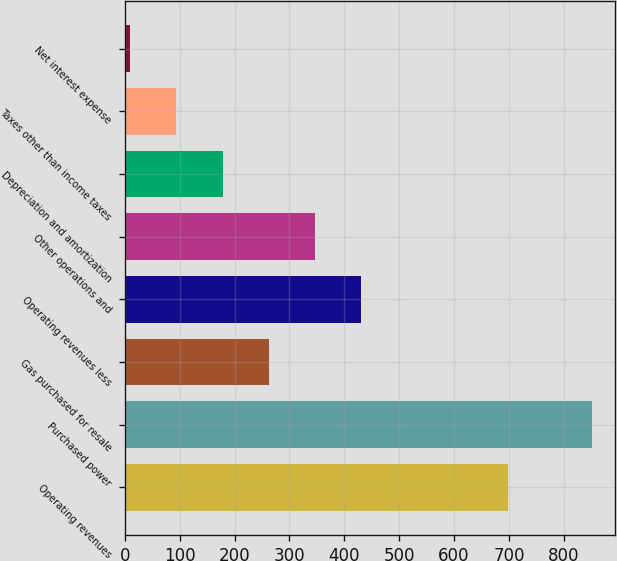<chart> <loc_0><loc_0><loc_500><loc_500><bar_chart><fcel>Operating revenues<fcel>Purchased power<fcel>Gas purchased for resale<fcel>Operating revenues less<fcel>Other operations and<fcel>Depreciation and amortization<fcel>Taxes other than income taxes<fcel>Net interest expense<nl><fcel>698<fcel>851<fcel>262.3<fcel>430.5<fcel>346.4<fcel>178.2<fcel>94.1<fcel>10<nl></chart> 